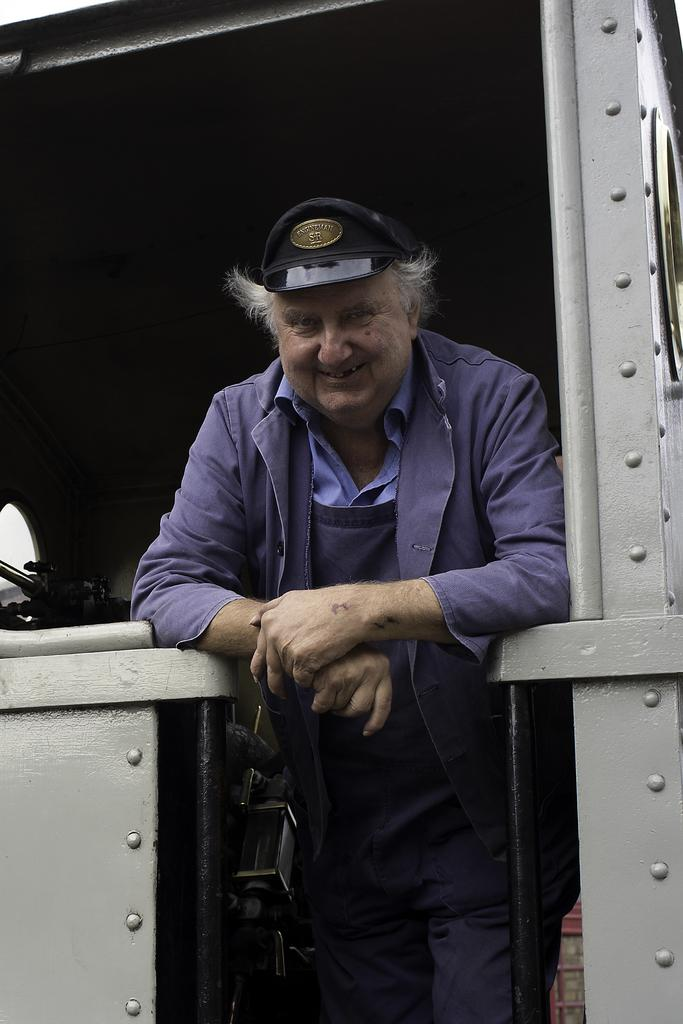Who is present in the image? There is a man in the image. What is the man standing on? The man is standing on a metal structure. What color is the jacket the man is wearing? The man is wearing a purple jacket. What type of headwear is the man wearing? The man is wearing a cap. What type of pants is the man wearing? The man is wearing trousers. What type of glue is the man using to fix the volleyball in the image? There is no glue or volleyball present in the image; it only features a man standing on a metal structure while wearing a purple jacket, cap, and trousers. 